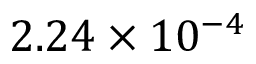Convert formula to latex. <formula><loc_0><loc_0><loc_500><loc_500>2 . 2 4 \times 1 0 ^ { - 4 }</formula> 